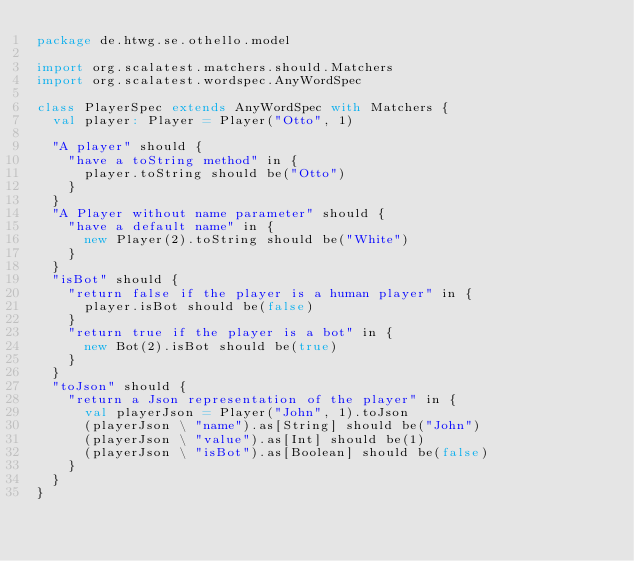<code> <loc_0><loc_0><loc_500><loc_500><_Scala_>package de.htwg.se.othello.model

import org.scalatest.matchers.should.Matchers
import org.scalatest.wordspec.AnyWordSpec

class PlayerSpec extends AnyWordSpec with Matchers {
  val player: Player = Player("Otto", 1)

  "A player" should {
    "have a toString method" in {
      player.toString should be("Otto")
    }
  }
  "A Player without name parameter" should {
    "have a default name" in {
      new Player(2).toString should be("White")
    }
  }
  "isBot" should {
    "return false if the player is a human player" in {
      player.isBot should be(false)
    }
    "return true if the player is a bot" in {
      new Bot(2).isBot should be(true)
    }
  }
  "toJson" should {
    "return a Json representation of the player" in {
      val playerJson = Player("John", 1).toJson
      (playerJson \ "name").as[String] should be("John")
      (playerJson \ "value").as[Int] should be(1)
      (playerJson \ "isBot").as[Boolean] should be(false)
    }
  }
}
</code> 